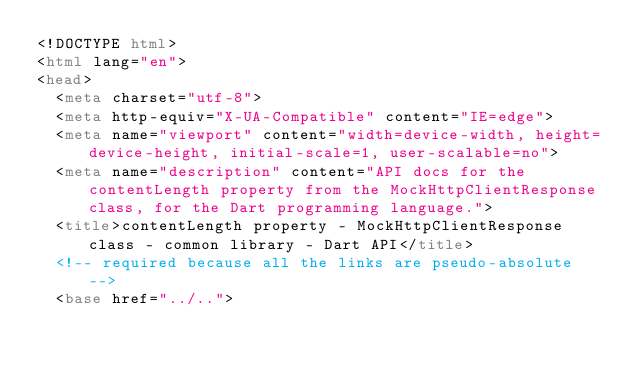Convert code to text. <code><loc_0><loc_0><loc_500><loc_500><_HTML_><!DOCTYPE html>
<html lang="en">
<head>
  <meta charset="utf-8">
  <meta http-equiv="X-UA-Compatible" content="IE=edge">
  <meta name="viewport" content="width=device-width, height=device-height, initial-scale=1, user-scalable=no">
  <meta name="description" content="API docs for the contentLength property from the MockHttpClientResponse class, for the Dart programming language.">
  <title>contentLength property - MockHttpClientResponse class - common library - Dart API</title>
  <!-- required because all the links are pseudo-absolute -->
  <base href="../..">
</code> 